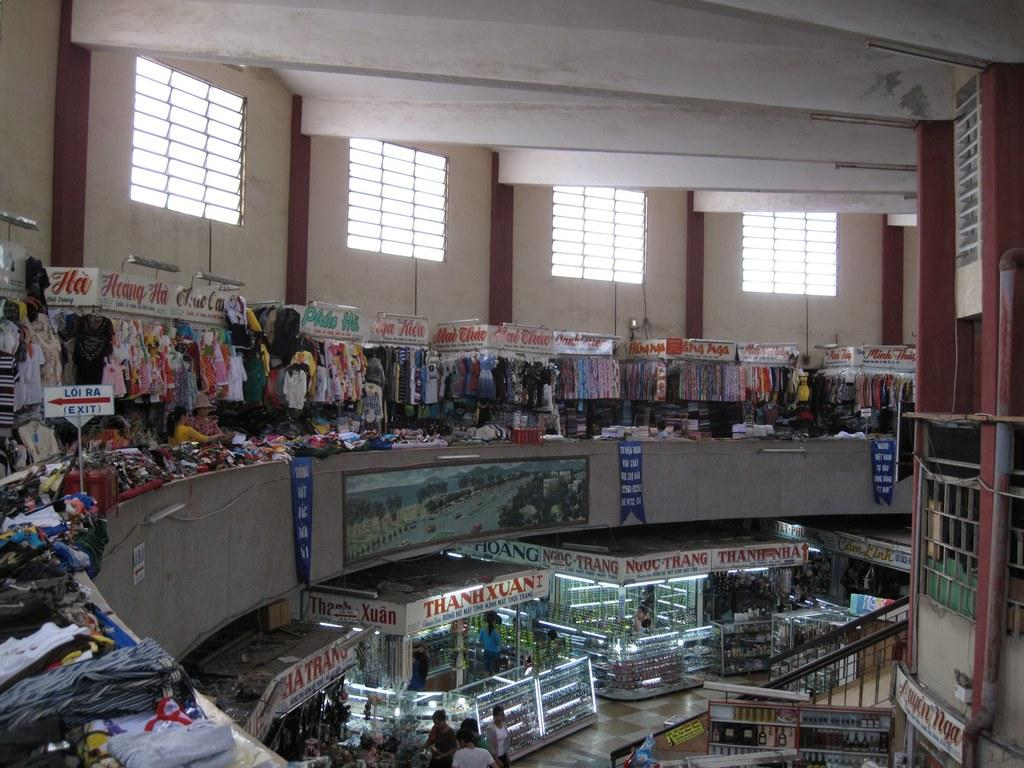<image>
Give a short and clear explanation of the subsequent image. An indoor marketplace with products from Huang Ha. 